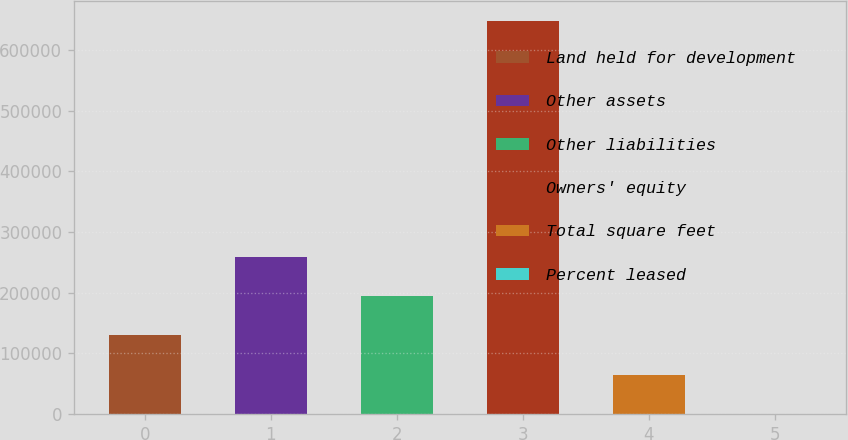<chart> <loc_0><loc_0><loc_500><loc_500><bar_chart><fcel>Land held for development<fcel>Other assets<fcel>Other liabilities<fcel>Owners' equity<fcel>Total square feet<fcel>Percent leased<nl><fcel>129698<fcel>259302<fcel>194500<fcel>648113<fcel>64896.3<fcel>94.4<nl></chart> 